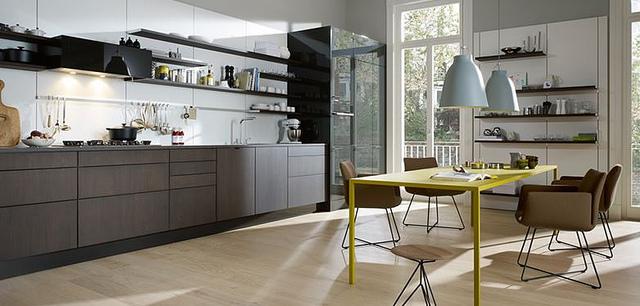What color are the cabinets?
Write a very short answer. Brown. Does this look like an updated kitchen?
Quick response, please. Yes. Who was cooking in this kitchen last evening?
Keep it brief. Mom. Is this kitchen in a suburban house?
Give a very brief answer. Yes. 